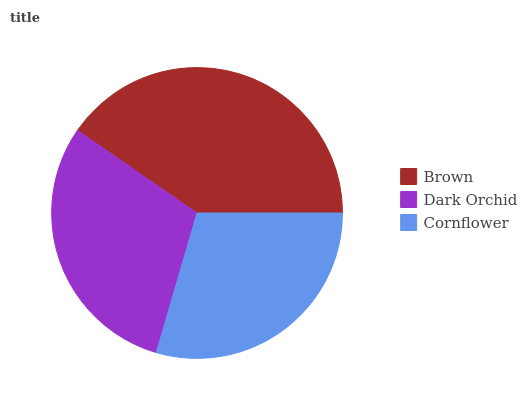Is Cornflower the minimum?
Answer yes or no. Yes. Is Brown the maximum?
Answer yes or no. Yes. Is Dark Orchid the minimum?
Answer yes or no. No. Is Dark Orchid the maximum?
Answer yes or no. No. Is Brown greater than Dark Orchid?
Answer yes or no. Yes. Is Dark Orchid less than Brown?
Answer yes or no. Yes. Is Dark Orchid greater than Brown?
Answer yes or no. No. Is Brown less than Dark Orchid?
Answer yes or no. No. Is Dark Orchid the high median?
Answer yes or no. Yes. Is Dark Orchid the low median?
Answer yes or no. Yes. Is Brown the high median?
Answer yes or no. No. Is Cornflower the low median?
Answer yes or no. No. 